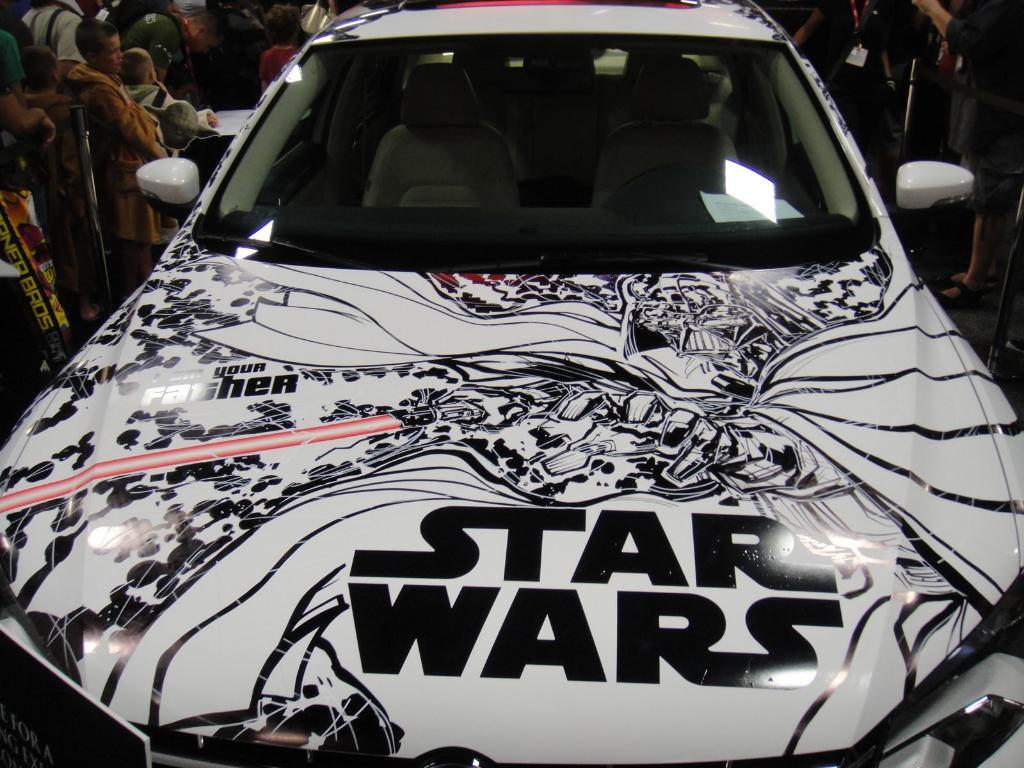What is the main subject of the image? The main subject of the image is a car. Can you describe any unique features of the car? The car has a design on it. Are there any people in the image? Yes, there are persons on both sides of the car. What hobbies do the persons on both sides of the car have in common? There is no information about the hobbies of the persons in the image, so we cannot determine if they have any in common. How many dimes can be seen on the car in the image? There are no dimes visible on the car in the image. 